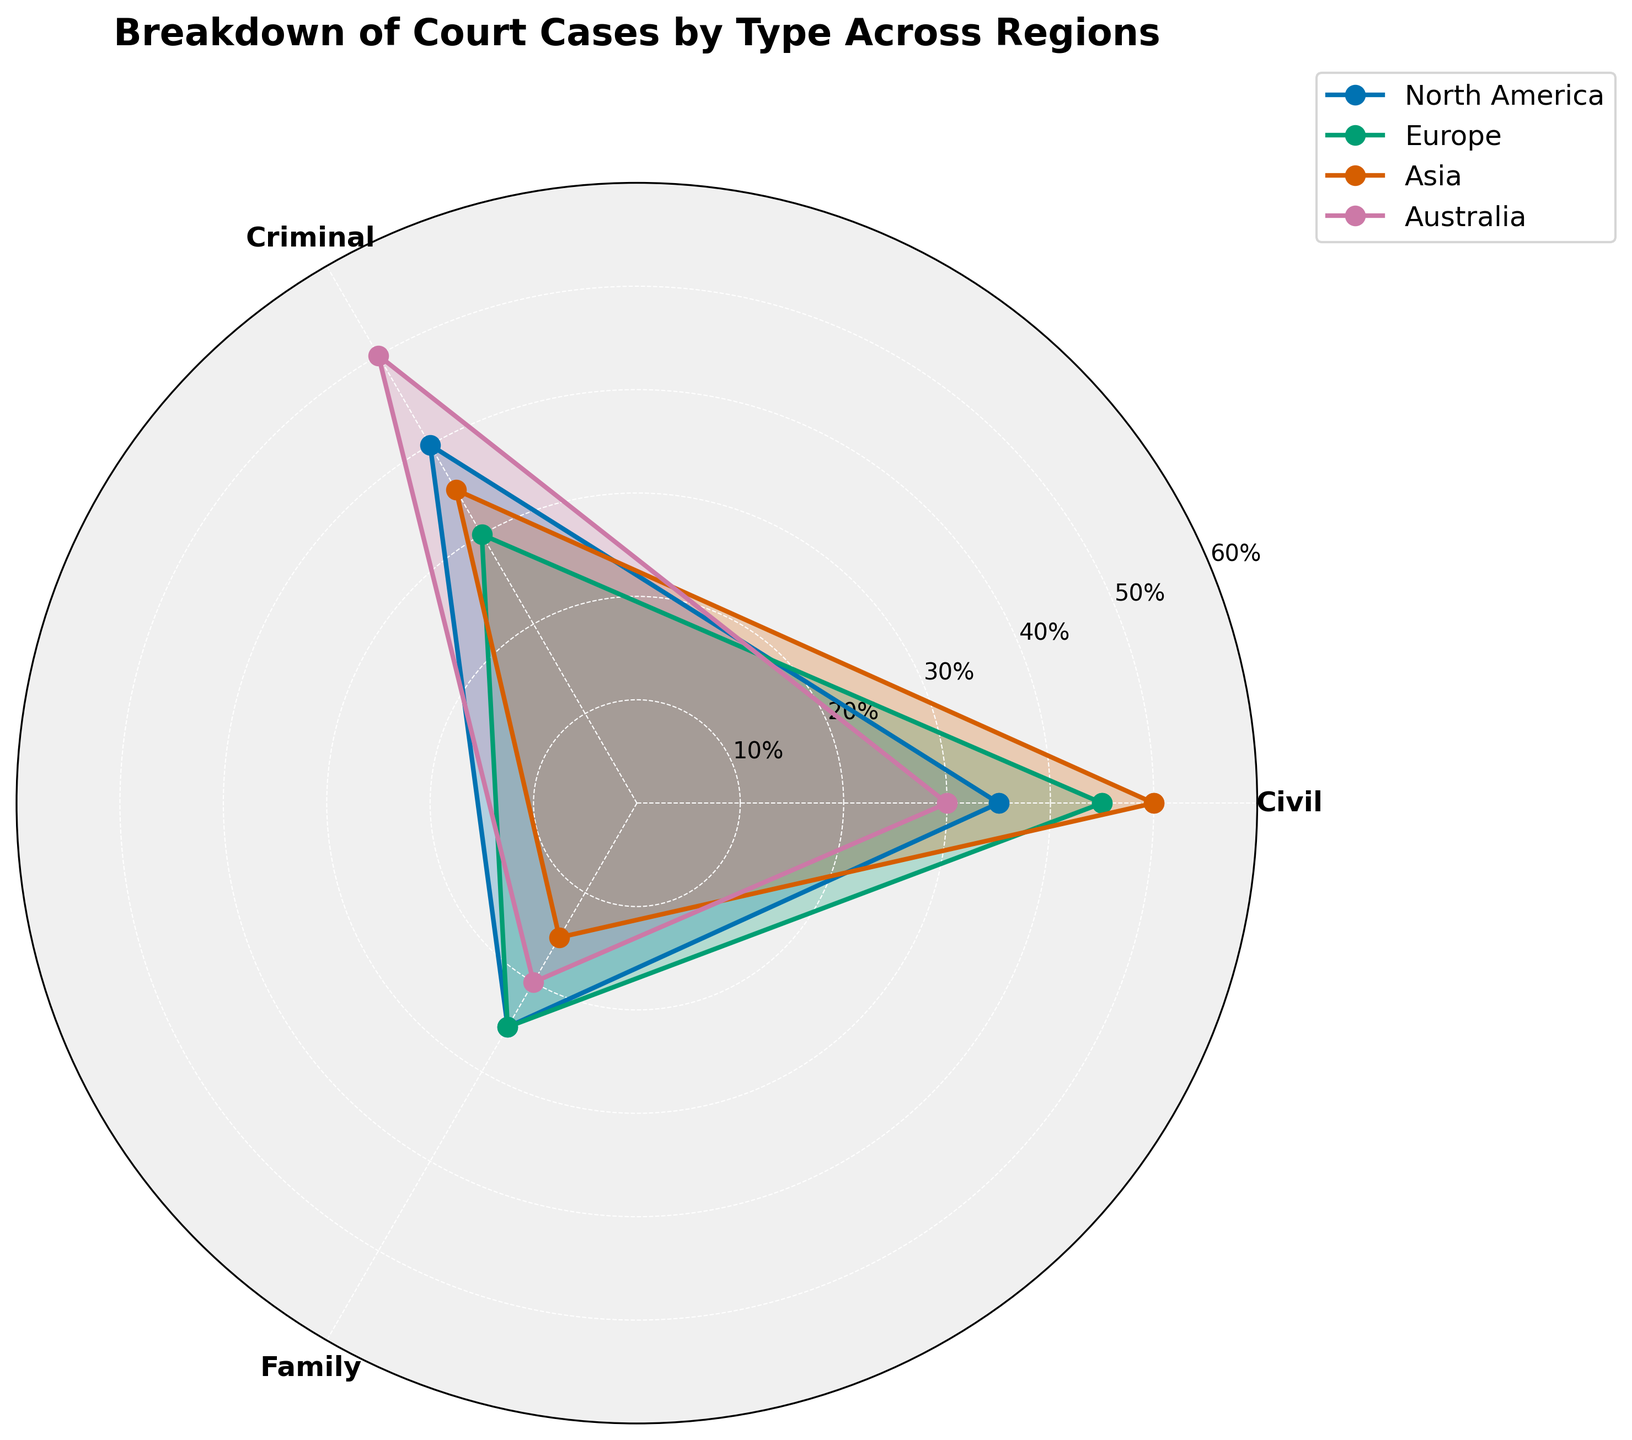What is the title of the figure? The title is the main text at the top of the figure that describes what the chart is about.
Answer: Breakdown of Court Cases by Type Across Regions Which region has the highest percentage of criminal cases? The region with the highest point on the criminal axis (usually labeled and color-coded) represents this value. Australia's criminal percentage is highest at 50%.
Answer: Australia What is the percentage difference between civil and family cases in Europe? Find the percentage for civil cases (45%) and family cases (25%) in Europe, then calculate the difference: 45% - 25% = 20%.
Answer: 20% Which region has the smallest percentage of family cases? Compare the plotted values for family cases across all regions. Asia's family case percentage is the smallest at 15%.
Answer: Asia How does the percentage of civil cases in North America compare to Asia? Look at the civil case percentages for North America (35%) and Asia (50%). North America's percentage is 15% less than Asia's.
Answer: 15% less In which region are criminal cases more prevalent than family cases by at least 30%? Look at differences between criminal and family case percentages for each region. Australia meets this condition with 50% criminal and 20% family cases, a 30% difference.
Answer: Australia How many regions have exactly 25% family cases? Identify the regions with family case percentages of 25%. Both North America and Europe have 25%.
Answer: 2 regions What is the average percentage of civil cases across all regions? Sum the civil case percentages (35% + 45% + 50% + 30%) and divide by the number of regions: (35 + 45 + 50 + 30) / 4 = 40%.
Answer: 40% In which region are civil cases more prevalent than criminal cases? Compare civil and criminal case percentages for each region. Europe and Asia have higher civil percentages than criminal.
Answer: Europe, Asia What is the total percentage of family cases across North America and Australia? Add the family case percentages for North America (25%) and Australia (20%): 25% + 20% = 45%.
Answer: 45% 